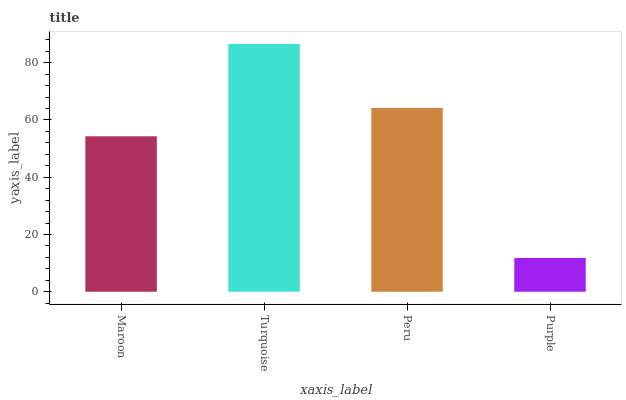Is Purple the minimum?
Answer yes or no. Yes. Is Turquoise the maximum?
Answer yes or no. Yes. Is Peru the minimum?
Answer yes or no. No. Is Peru the maximum?
Answer yes or no. No. Is Turquoise greater than Peru?
Answer yes or no. Yes. Is Peru less than Turquoise?
Answer yes or no. Yes. Is Peru greater than Turquoise?
Answer yes or no. No. Is Turquoise less than Peru?
Answer yes or no. No. Is Peru the high median?
Answer yes or no. Yes. Is Maroon the low median?
Answer yes or no. Yes. Is Turquoise the high median?
Answer yes or no. No. Is Turquoise the low median?
Answer yes or no. No. 